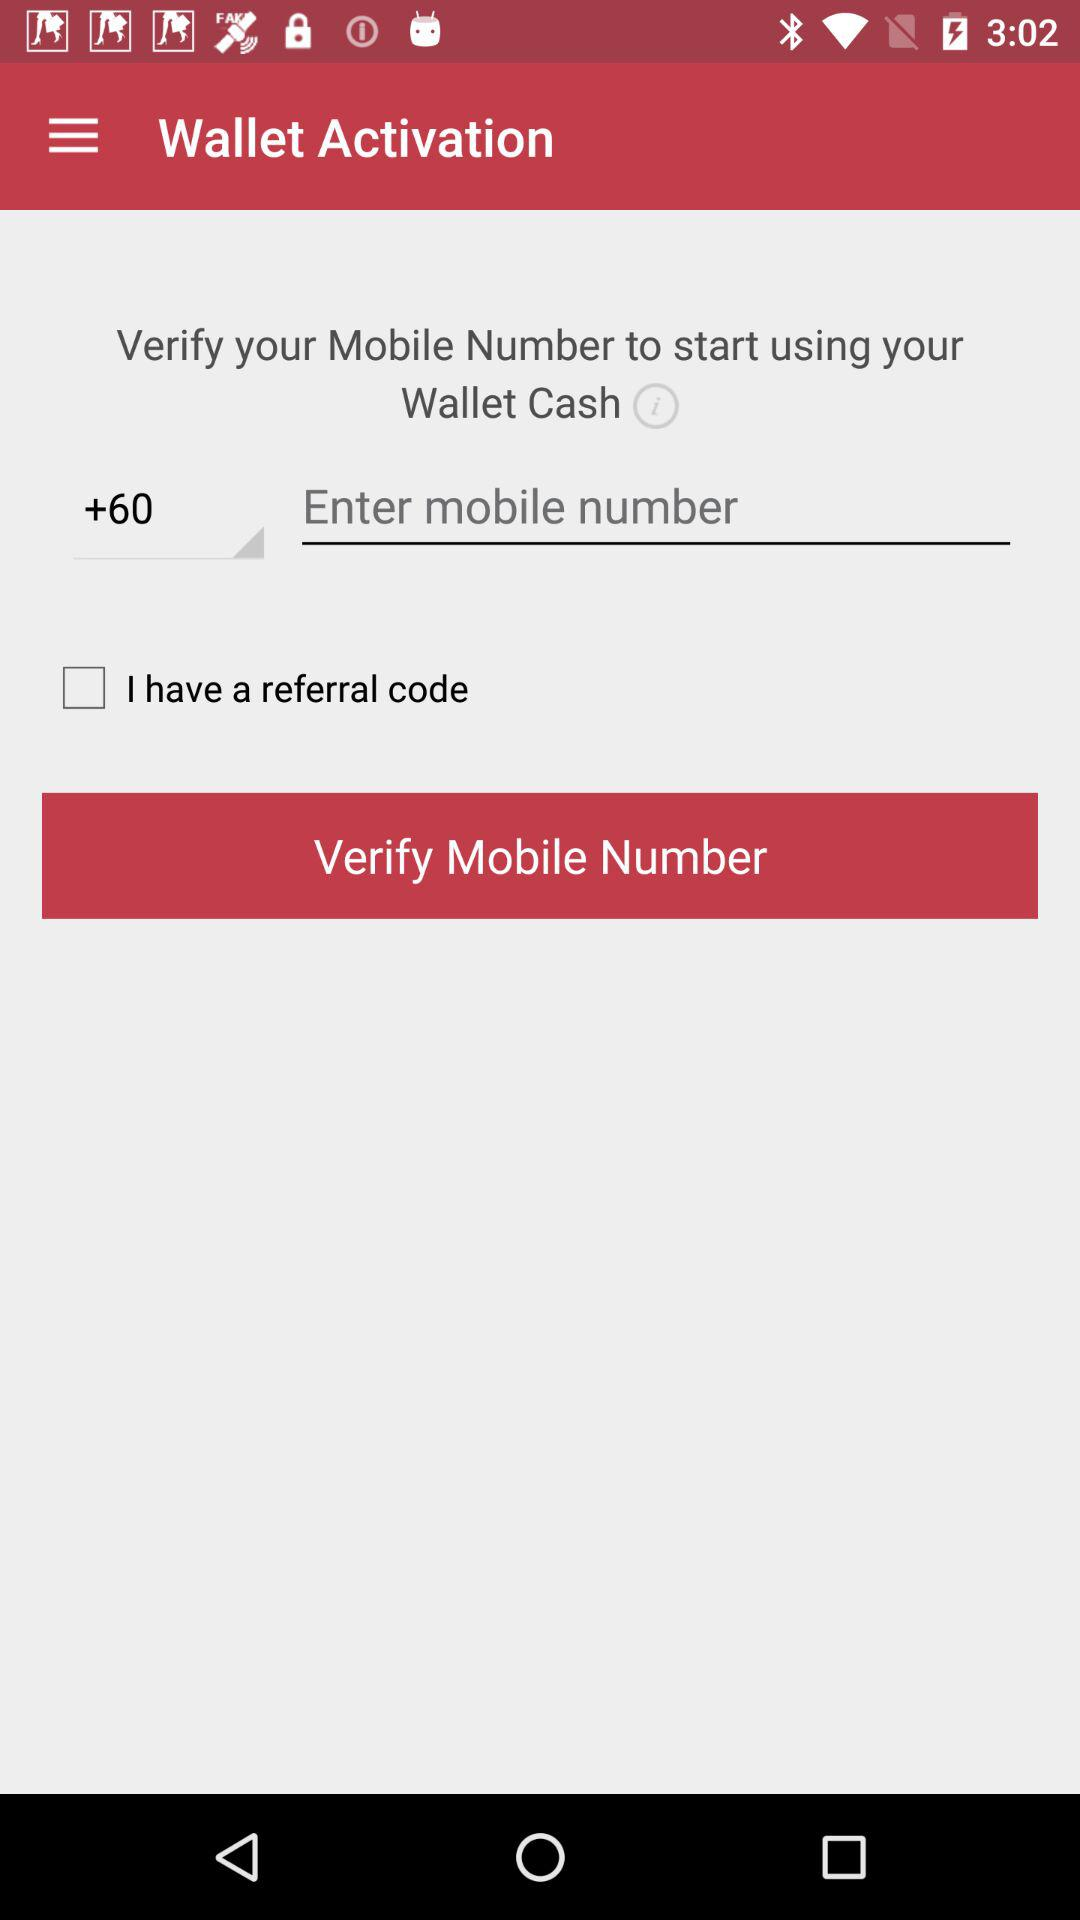What is the status of "I have a referral code"? The status is "off". 